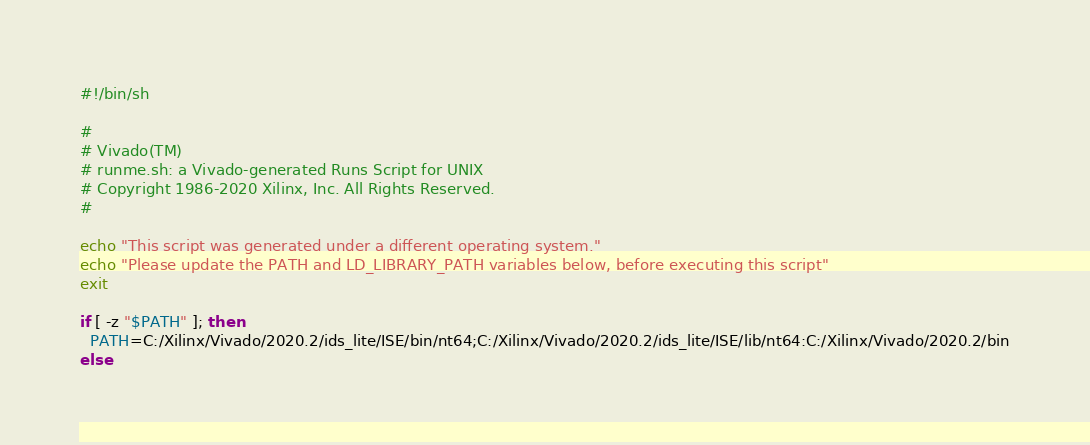<code> <loc_0><loc_0><loc_500><loc_500><_Bash_>#!/bin/sh

# 
# Vivado(TM)
# runme.sh: a Vivado-generated Runs Script for UNIX
# Copyright 1986-2020 Xilinx, Inc. All Rights Reserved.
# 

echo "This script was generated under a different operating system."
echo "Please update the PATH and LD_LIBRARY_PATH variables below, before executing this script"
exit

if [ -z "$PATH" ]; then
  PATH=C:/Xilinx/Vivado/2020.2/ids_lite/ISE/bin/nt64;C:/Xilinx/Vivado/2020.2/ids_lite/ISE/lib/nt64:C:/Xilinx/Vivado/2020.2/bin
else</code> 